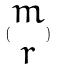<formula> <loc_0><loc_0><loc_500><loc_500>( \begin{matrix} m \\ r \end{matrix} )</formula> 